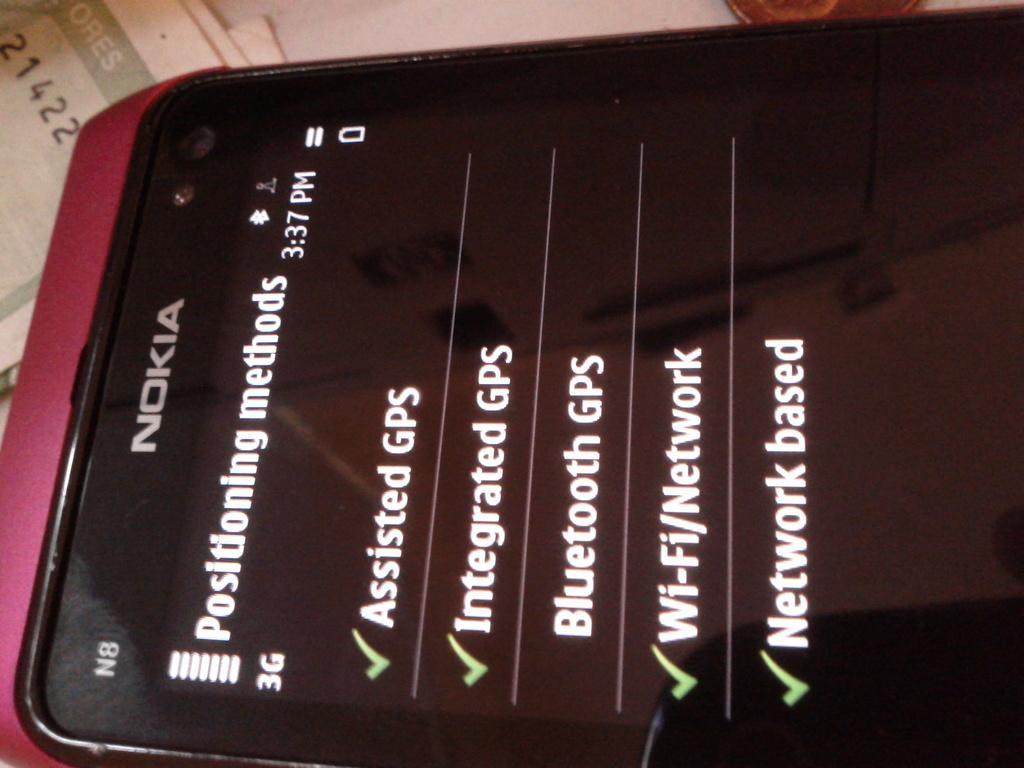Provide a one-sentence caption for the provided image. A checklist is displayed on the screen of a Nokia phone. 